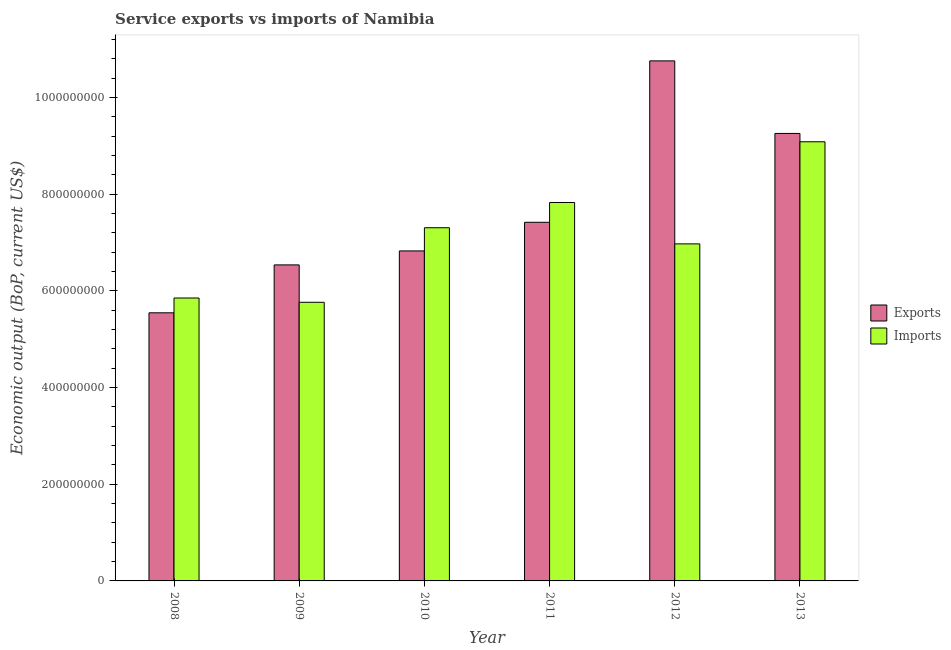How many different coloured bars are there?
Make the answer very short. 2. Are the number of bars per tick equal to the number of legend labels?
Your answer should be compact. Yes. What is the label of the 2nd group of bars from the left?
Provide a succinct answer. 2009. In how many cases, is the number of bars for a given year not equal to the number of legend labels?
Keep it short and to the point. 0. What is the amount of service exports in 2012?
Provide a succinct answer. 1.08e+09. Across all years, what is the maximum amount of service imports?
Your answer should be compact. 9.09e+08. Across all years, what is the minimum amount of service exports?
Make the answer very short. 5.55e+08. In which year was the amount of service imports minimum?
Provide a short and direct response. 2009. What is the total amount of service imports in the graph?
Provide a short and direct response. 4.28e+09. What is the difference between the amount of service imports in 2009 and that in 2010?
Provide a short and direct response. -1.54e+08. What is the difference between the amount of service exports in 2012 and the amount of service imports in 2010?
Your answer should be very brief. 3.93e+08. What is the average amount of service imports per year?
Give a very brief answer. 7.14e+08. What is the ratio of the amount of service imports in 2010 to that in 2011?
Your response must be concise. 0.93. Is the difference between the amount of service exports in 2008 and 2013 greater than the difference between the amount of service imports in 2008 and 2013?
Ensure brevity in your answer.  No. What is the difference between the highest and the second highest amount of service exports?
Your answer should be very brief. 1.50e+08. What is the difference between the highest and the lowest amount of service imports?
Your response must be concise. 3.32e+08. Is the sum of the amount of service imports in 2008 and 2011 greater than the maximum amount of service exports across all years?
Your answer should be compact. Yes. What does the 1st bar from the left in 2011 represents?
Your answer should be very brief. Exports. What does the 2nd bar from the right in 2009 represents?
Ensure brevity in your answer.  Exports. How many bars are there?
Provide a succinct answer. 12. How many years are there in the graph?
Give a very brief answer. 6. What is the difference between two consecutive major ticks on the Y-axis?
Your answer should be very brief. 2.00e+08. Are the values on the major ticks of Y-axis written in scientific E-notation?
Provide a short and direct response. No. Does the graph contain any zero values?
Make the answer very short. No. How many legend labels are there?
Offer a terse response. 2. What is the title of the graph?
Provide a succinct answer. Service exports vs imports of Namibia. Does "State government" appear as one of the legend labels in the graph?
Provide a short and direct response. No. What is the label or title of the X-axis?
Your answer should be very brief. Year. What is the label or title of the Y-axis?
Your answer should be very brief. Economic output (BoP, current US$). What is the Economic output (BoP, current US$) in Exports in 2008?
Your response must be concise. 5.55e+08. What is the Economic output (BoP, current US$) of Imports in 2008?
Your response must be concise. 5.85e+08. What is the Economic output (BoP, current US$) in Exports in 2009?
Offer a terse response. 6.54e+08. What is the Economic output (BoP, current US$) in Imports in 2009?
Your answer should be very brief. 5.76e+08. What is the Economic output (BoP, current US$) of Exports in 2010?
Provide a succinct answer. 6.83e+08. What is the Economic output (BoP, current US$) of Imports in 2010?
Make the answer very short. 7.31e+08. What is the Economic output (BoP, current US$) of Exports in 2011?
Offer a terse response. 7.42e+08. What is the Economic output (BoP, current US$) of Imports in 2011?
Ensure brevity in your answer.  7.83e+08. What is the Economic output (BoP, current US$) in Exports in 2012?
Ensure brevity in your answer.  1.08e+09. What is the Economic output (BoP, current US$) of Imports in 2012?
Make the answer very short. 6.97e+08. What is the Economic output (BoP, current US$) of Exports in 2013?
Keep it short and to the point. 9.26e+08. What is the Economic output (BoP, current US$) of Imports in 2013?
Offer a very short reply. 9.09e+08. Across all years, what is the maximum Economic output (BoP, current US$) of Exports?
Provide a succinct answer. 1.08e+09. Across all years, what is the maximum Economic output (BoP, current US$) in Imports?
Your answer should be compact. 9.09e+08. Across all years, what is the minimum Economic output (BoP, current US$) of Exports?
Give a very brief answer. 5.55e+08. Across all years, what is the minimum Economic output (BoP, current US$) in Imports?
Provide a succinct answer. 5.76e+08. What is the total Economic output (BoP, current US$) of Exports in the graph?
Provide a short and direct response. 4.63e+09. What is the total Economic output (BoP, current US$) in Imports in the graph?
Keep it short and to the point. 4.28e+09. What is the difference between the Economic output (BoP, current US$) of Exports in 2008 and that in 2009?
Your answer should be very brief. -9.91e+07. What is the difference between the Economic output (BoP, current US$) of Imports in 2008 and that in 2009?
Your response must be concise. 8.86e+06. What is the difference between the Economic output (BoP, current US$) in Exports in 2008 and that in 2010?
Give a very brief answer. -1.28e+08. What is the difference between the Economic output (BoP, current US$) of Imports in 2008 and that in 2010?
Your answer should be compact. -1.45e+08. What is the difference between the Economic output (BoP, current US$) of Exports in 2008 and that in 2011?
Your response must be concise. -1.87e+08. What is the difference between the Economic output (BoP, current US$) in Imports in 2008 and that in 2011?
Make the answer very short. -1.98e+08. What is the difference between the Economic output (BoP, current US$) of Exports in 2008 and that in 2012?
Your answer should be compact. -5.21e+08. What is the difference between the Economic output (BoP, current US$) of Imports in 2008 and that in 2012?
Offer a terse response. -1.12e+08. What is the difference between the Economic output (BoP, current US$) of Exports in 2008 and that in 2013?
Offer a very short reply. -3.71e+08. What is the difference between the Economic output (BoP, current US$) of Imports in 2008 and that in 2013?
Your answer should be compact. -3.23e+08. What is the difference between the Economic output (BoP, current US$) in Exports in 2009 and that in 2010?
Your answer should be very brief. -2.89e+07. What is the difference between the Economic output (BoP, current US$) of Imports in 2009 and that in 2010?
Keep it short and to the point. -1.54e+08. What is the difference between the Economic output (BoP, current US$) in Exports in 2009 and that in 2011?
Make the answer very short. -8.81e+07. What is the difference between the Economic output (BoP, current US$) in Imports in 2009 and that in 2011?
Keep it short and to the point. -2.06e+08. What is the difference between the Economic output (BoP, current US$) of Exports in 2009 and that in 2012?
Your answer should be compact. -4.22e+08. What is the difference between the Economic output (BoP, current US$) in Imports in 2009 and that in 2012?
Keep it short and to the point. -1.21e+08. What is the difference between the Economic output (BoP, current US$) in Exports in 2009 and that in 2013?
Your answer should be compact. -2.72e+08. What is the difference between the Economic output (BoP, current US$) in Imports in 2009 and that in 2013?
Your response must be concise. -3.32e+08. What is the difference between the Economic output (BoP, current US$) of Exports in 2010 and that in 2011?
Give a very brief answer. -5.92e+07. What is the difference between the Economic output (BoP, current US$) of Imports in 2010 and that in 2011?
Ensure brevity in your answer.  -5.22e+07. What is the difference between the Economic output (BoP, current US$) in Exports in 2010 and that in 2012?
Offer a terse response. -3.93e+08. What is the difference between the Economic output (BoP, current US$) of Imports in 2010 and that in 2012?
Offer a terse response. 3.34e+07. What is the difference between the Economic output (BoP, current US$) of Exports in 2010 and that in 2013?
Offer a terse response. -2.43e+08. What is the difference between the Economic output (BoP, current US$) in Imports in 2010 and that in 2013?
Provide a succinct answer. -1.78e+08. What is the difference between the Economic output (BoP, current US$) in Exports in 2011 and that in 2012?
Your answer should be very brief. -3.34e+08. What is the difference between the Economic output (BoP, current US$) in Imports in 2011 and that in 2012?
Your answer should be compact. 8.56e+07. What is the difference between the Economic output (BoP, current US$) in Exports in 2011 and that in 2013?
Make the answer very short. -1.84e+08. What is the difference between the Economic output (BoP, current US$) of Imports in 2011 and that in 2013?
Your response must be concise. -1.26e+08. What is the difference between the Economic output (BoP, current US$) in Exports in 2012 and that in 2013?
Offer a very short reply. 1.50e+08. What is the difference between the Economic output (BoP, current US$) in Imports in 2012 and that in 2013?
Offer a terse response. -2.11e+08. What is the difference between the Economic output (BoP, current US$) in Exports in 2008 and the Economic output (BoP, current US$) in Imports in 2009?
Offer a terse response. -2.17e+07. What is the difference between the Economic output (BoP, current US$) in Exports in 2008 and the Economic output (BoP, current US$) in Imports in 2010?
Make the answer very short. -1.76e+08. What is the difference between the Economic output (BoP, current US$) in Exports in 2008 and the Economic output (BoP, current US$) in Imports in 2011?
Keep it short and to the point. -2.28e+08. What is the difference between the Economic output (BoP, current US$) of Exports in 2008 and the Economic output (BoP, current US$) of Imports in 2012?
Give a very brief answer. -1.43e+08. What is the difference between the Economic output (BoP, current US$) in Exports in 2008 and the Economic output (BoP, current US$) in Imports in 2013?
Keep it short and to the point. -3.54e+08. What is the difference between the Economic output (BoP, current US$) of Exports in 2009 and the Economic output (BoP, current US$) of Imports in 2010?
Your answer should be very brief. -7.69e+07. What is the difference between the Economic output (BoP, current US$) of Exports in 2009 and the Economic output (BoP, current US$) of Imports in 2011?
Provide a succinct answer. -1.29e+08. What is the difference between the Economic output (BoP, current US$) of Exports in 2009 and the Economic output (BoP, current US$) of Imports in 2012?
Your response must be concise. -4.35e+07. What is the difference between the Economic output (BoP, current US$) in Exports in 2009 and the Economic output (BoP, current US$) in Imports in 2013?
Provide a short and direct response. -2.55e+08. What is the difference between the Economic output (BoP, current US$) in Exports in 2010 and the Economic output (BoP, current US$) in Imports in 2011?
Provide a succinct answer. -1.00e+08. What is the difference between the Economic output (BoP, current US$) in Exports in 2010 and the Economic output (BoP, current US$) in Imports in 2012?
Give a very brief answer. -1.45e+07. What is the difference between the Economic output (BoP, current US$) of Exports in 2010 and the Economic output (BoP, current US$) of Imports in 2013?
Give a very brief answer. -2.26e+08. What is the difference between the Economic output (BoP, current US$) in Exports in 2011 and the Economic output (BoP, current US$) in Imports in 2012?
Provide a succinct answer. 4.47e+07. What is the difference between the Economic output (BoP, current US$) of Exports in 2011 and the Economic output (BoP, current US$) of Imports in 2013?
Your response must be concise. -1.67e+08. What is the difference between the Economic output (BoP, current US$) in Exports in 2012 and the Economic output (BoP, current US$) in Imports in 2013?
Your answer should be compact. 1.67e+08. What is the average Economic output (BoP, current US$) of Exports per year?
Make the answer very short. 7.72e+08. What is the average Economic output (BoP, current US$) of Imports per year?
Give a very brief answer. 7.14e+08. In the year 2008, what is the difference between the Economic output (BoP, current US$) in Exports and Economic output (BoP, current US$) in Imports?
Provide a short and direct response. -3.06e+07. In the year 2009, what is the difference between the Economic output (BoP, current US$) of Exports and Economic output (BoP, current US$) of Imports?
Your answer should be very brief. 7.74e+07. In the year 2010, what is the difference between the Economic output (BoP, current US$) of Exports and Economic output (BoP, current US$) of Imports?
Keep it short and to the point. -4.79e+07. In the year 2011, what is the difference between the Economic output (BoP, current US$) of Exports and Economic output (BoP, current US$) of Imports?
Give a very brief answer. -4.10e+07. In the year 2012, what is the difference between the Economic output (BoP, current US$) of Exports and Economic output (BoP, current US$) of Imports?
Your answer should be very brief. 3.79e+08. In the year 2013, what is the difference between the Economic output (BoP, current US$) of Exports and Economic output (BoP, current US$) of Imports?
Give a very brief answer. 1.73e+07. What is the ratio of the Economic output (BoP, current US$) of Exports in 2008 to that in 2009?
Your response must be concise. 0.85. What is the ratio of the Economic output (BoP, current US$) in Imports in 2008 to that in 2009?
Provide a short and direct response. 1.02. What is the ratio of the Economic output (BoP, current US$) of Exports in 2008 to that in 2010?
Keep it short and to the point. 0.81. What is the ratio of the Economic output (BoP, current US$) in Imports in 2008 to that in 2010?
Your answer should be compact. 0.8. What is the ratio of the Economic output (BoP, current US$) of Exports in 2008 to that in 2011?
Ensure brevity in your answer.  0.75. What is the ratio of the Economic output (BoP, current US$) in Imports in 2008 to that in 2011?
Give a very brief answer. 0.75. What is the ratio of the Economic output (BoP, current US$) in Exports in 2008 to that in 2012?
Provide a succinct answer. 0.52. What is the ratio of the Economic output (BoP, current US$) of Imports in 2008 to that in 2012?
Your answer should be very brief. 0.84. What is the ratio of the Economic output (BoP, current US$) of Exports in 2008 to that in 2013?
Your answer should be compact. 0.6. What is the ratio of the Economic output (BoP, current US$) in Imports in 2008 to that in 2013?
Offer a terse response. 0.64. What is the ratio of the Economic output (BoP, current US$) of Exports in 2009 to that in 2010?
Give a very brief answer. 0.96. What is the ratio of the Economic output (BoP, current US$) in Imports in 2009 to that in 2010?
Make the answer very short. 0.79. What is the ratio of the Economic output (BoP, current US$) in Exports in 2009 to that in 2011?
Your answer should be compact. 0.88. What is the ratio of the Economic output (BoP, current US$) in Imports in 2009 to that in 2011?
Offer a terse response. 0.74. What is the ratio of the Economic output (BoP, current US$) in Exports in 2009 to that in 2012?
Your answer should be very brief. 0.61. What is the ratio of the Economic output (BoP, current US$) of Imports in 2009 to that in 2012?
Offer a very short reply. 0.83. What is the ratio of the Economic output (BoP, current US$) in Exports in 2009 to that in 2013?
Your answer should be very brief. 0.71. What is the ratio of the Economic output (BoP, current US$) of Imports in 2009 to that in 2013?
Keep it short and to the point. 0.63. What is the ratio of the Economic output (BoP, current US$) in Exports in 2010 to that in 2011?
Give a very brief answer. 0.92. What is the ratio of the Economic output (BoP, current US$) of Imports in 2010 to that in 2011?
Make the answer very short. 0.93. What is the ratio of the Economic output (BoP, current US$) of Exports in 2010 to that in 2012?
Offer a terse response. 0.63. What is the ratio of the Economic output (BoP, current US$) of Imports in 2010 to that in 2012?
Ensure brevity in your answer.  1.05. What is the ratio of the Economic output (BoP, current US$) in Exports in 2010 to that in 2013?
Ensure brevity in your answer.  0.74. What is the ratio of the Economic output (BoP, current US$) of Imports in 2010 to that in 2013?
Offer a very short reply. 0.8. What is the ratio of the Economic output (BoP, current US$) in Exports in 2011 to that in 2012?
Ensure brevity in your answer.  0.69. What is the ratio of the Economic output (BoP, current US$) of Imports in 2011 to that in 2012?
Your answer should be compact. 1.12. What is the ratio of the Economic output (BoP, current US$) of Exports in 2011 to that in 2013?
Your answer should be compact. 0.8. What is the ratio of the Economic output (BoP, current US$) in Imports in 2011 to that in 2013?
Offer a terse response. 0.86. What is the ratio of the Economic output (BoP, current US$) in Exports in 2012 to that in 2013?
Your response must be concise. 1.16. What is the ratio of the Economic output (BoP, current US$) of Imports in 2012 to that in 2013?
Keep it short and to the point. 0.77. What is the difference between the highest and the second highest Economic output (BoP, current US$) of Exports?
Your answer should be very brief. 1.50e+08. What is the difference between the highest and the second highest Economic output (BoP, current US$) of Imports?
Provide a succinct answer. 1.26e+08. What is the difference between the highest and the lowest Economic output (BoP, current US$) in Exports?
Your answer should be very brief. 5.21e+08. What is the difference between the highest and the lowest Economic output (BoP, current US$) in Imports?
Your response must be concise. 3.32e+08. 